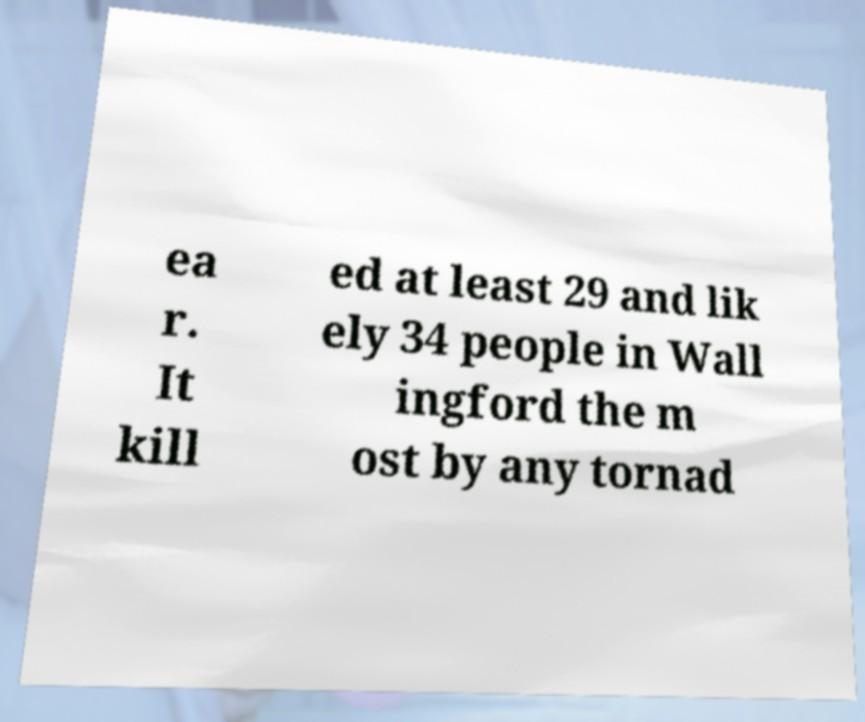Please read and relay the text visible in this image. What does it say? ea r. It kill ed at least 29 and lik ely 34 people in Wall ingford the m ost by any tornad 